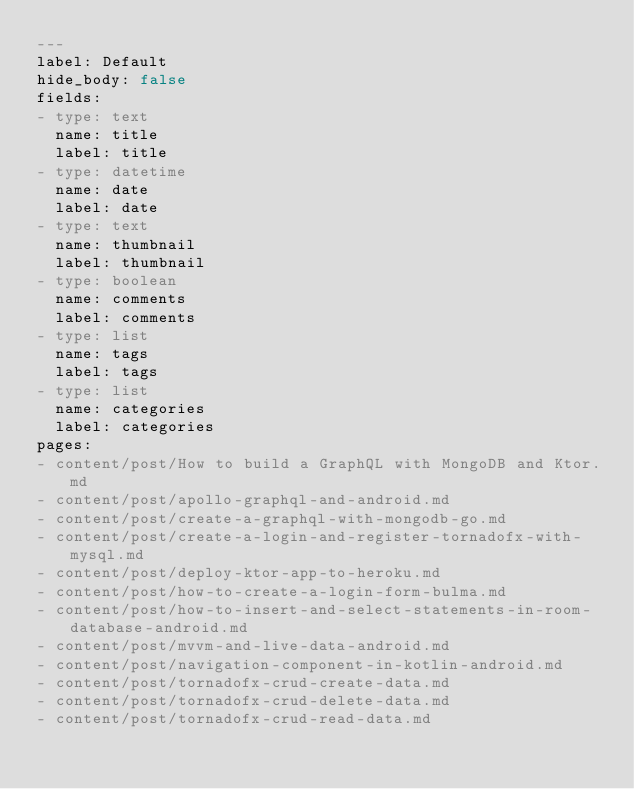<code> <loc_0><loc_0><loc_500><loc_500><_YAML_>---
label: Default
hide_body: false
fields:
- type: text
  name: title
  label: title
- type: datetime
  name: date
  label: date
- type: text
  name: thumbnail
  label: thumbnail
- type: boolean
  name: comments
  label: comments
- type: list
  name: tags
  label: tags
- type: list
  name: categories
  label: categories
pages:
- content/post/How to build a GraphQL with MongoDB and Ktor.md
- content/post/apollo-graphql-and-android.md
- content/post/create-a-graphql-with-mongodb-go.md
- content/post/create-a-login-and-register-tornadofx-with-mysql.md
- content/post/deploy-ktor-app-to-heroku.md
- content/post/how-to-create-a-login-form-bulma.md
- content/post/how-to-insert-and-select-statements-in-room-database-android.md
- content/post/mvvm-and-live-data-android.md
- content/post/navigation-component-in-kotlin-android.md
- content/post/tornadofx-crud-create-data.md
- content/post/tornadofx-crud-delete-data.md
- content/post/tornadofx-crud-read-data.md</code> 